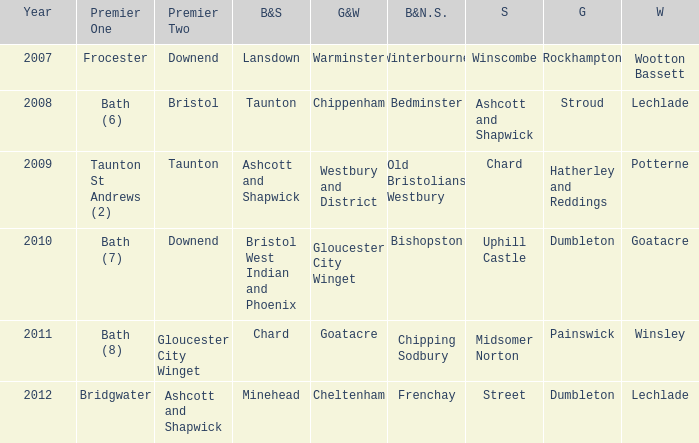Who many times is gloucestershire is painswick? 1.0. 